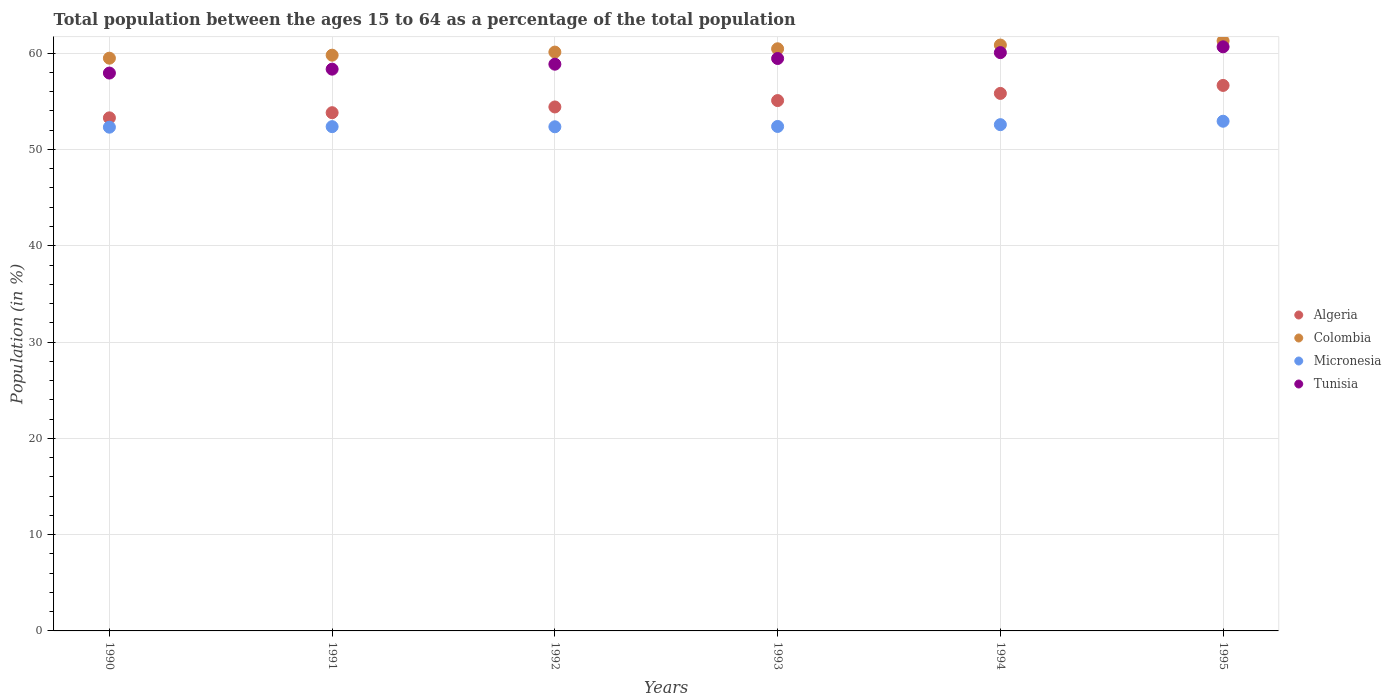How many different coloured dotlines are there?
Your answer should be very brief. 4. Is the number of dotlines equal to the number of legend labels?
Your answer should be compact. Yes. What is the percentage of the population ages 15 to 64 in Colombia in 1991?
Provide a succinct answer. 59.79. Across all years, what is the maximum percentage of the population ages 15 to 64 in Tunisia?
Provide a short and direct response. 60.66. Across all years, what is the minimum percentage of the population ages 15 to 64 in Algeria?
Offer a very short reply. 53.28. In which year was the percentage of the population ages 15 to 64 in Micronesia minimum?
Ensure brevity in your answer.  1990. What is the total percentage of the population ages 15 to 64 in Tunisia in the graph?
Give a very brief answer. 355.3. What is the difference between the percentage of the population ages 15 to 64 in Colombia in 1990 and that in 1992?
Make the answer very short. -0.63. What is the difference between the percentage of the population ages 15 to 64 in Algeria in 1993 and the percentage of the population ages 15 to 64 in Tunisia in 1994?
Offer a terse response. -4.98. What is the average percentage of the population ages 15 to 64 in Tunisia per year?
Offer a very short reply. 59.22. In the year 1992, what is the difference between the percentage of the population ages 15 to 64 in Micronesia and percentage of the population ages 15 to 64 in Tunisia?
Your answer should be compact. -6.5. What is the ratio of the percentage of the population ages 15 to 64 in Algeria in 1991 to that in 1994?
Offer a terse response. 0.96. What is the difference between the highest and the second highest percentage of the population ages 15 to 64 in Colombia?
Offer a very short reply. 0.43. What is the difference between the highest and the lowest percentage of the population ages 15 to 64 in Colombia?
Offer a terse response. 1.8. In how many years, is the percentage of the population ages 15 to 64 in Tunisia greater than the average percentage of the population ages 15 to 64 in Tunisia taken over all years?
Provide a succinct answer. 3. Is it the case that in every year, the sum of the percentage of the population ages 15 to 64 in Algeria and percentage of the population ages 15 to 64 in Tunisia  is greater than the percentage of the population ages 15 to 64 in Colombia?
Give a very brief answer. Yes. Does the percentage of the population ages 15 to 64 in Micronesia monotonically increase over the years?
Give a very brief answer. No. Is the percentage of the population ages 15 to 64 in Micronesia strictly greater than the percentage of the population ages 15 to 64 in Tunisia over the years?
Your answer should be very brief. No. Is the percentage of the population ages 15 to 64 in Colombia strictly less than the percentage of the population ages 15 to 64 in Tunisia over the years?
Your answer should be compact. No. How many years are there in the graph?
Give a very brief answer. 6. What is the difference between two consecutive major ticks on the Y-axis?
Your answer should be very brief. 10. Does the graph contain any zero values?
Offer a very short reply. No. Does the graph contain grids?
Your answer should be very brief. Yes. Where does the legend appear in the graph?
Your answer should be very brief. Center right. What is the title of the graph?
Offer a very short reply. Total population between the ages 15 to 64 as a percentage of the total population. What is the label or title of the X-axis?
Give a very brief answer. Years. What is the label or title of the Y-axis?
Your response must be concise. Population (in %). What is the Population (in %) in Algeria in 1990?
Keep it short and to the point. 53.28. What is the Population (in %) in Colombia in 1990?
Ensure brevity in your answer.  59.48. What is the Population (in %) of Micronesia in 1990?
Ensure brevity in your answer.  52.31. What is the Population (in %) in Tunisia in 1990?
Offer a very short reply. 57.94. What is the Population (in %) of Algeria in 1991?
Give a very brief answer. 53.82. What is the Population (in %) in Colombia in 1991?
Offer a terse response. 59.79. What is the Population (in %) in Micronesia in 1991?
Your answer should be compact. 52.37. What is the Population (in %) in Tunisia in 1991?
Make the answer very short. 58.34. What is the Population (in %) of Algeria in 1992?
Give a very brief answer. 54.42. What is the Population (in %) in Colombia in 1992?
Provide a short and direct response. 60.11. What is the Population (in %) in Micronesia in 1992?
Provide a short and direct response. 52.36. What is the Population (in %) in Tunisia in 1992?
Your answer should be compact. 58.86. What is the Population (in %) in Algeria in 1993?
Give a very brief answer. 55.08. What is the Population (in %) in Colombia in 1993?
Keep it short and to the point. 60.46. What is the Population (in %) in Micronesia in 1993?
Your answer should be very brief. 52.39. What is the Population (in %) in Tunisia in 1993?
Offer a terse response. 59.45. What is the Population (in %) in Algeria in 1994?
Your response must be concise. 55.82. What is the Population (in %) in Colombia in 1994?
Provide a succinct answer. 60.84. What is the Population (in %) in Micronesia in 1994?
Give a very brief answer. 52.58. What is the Population (in %) in Tunisia in 1994?
Give a very brief answer. 60.06. What is the Population (in %) in Algeria in 1995?
Provide a succinct answer. 56.65. What is the Population (in %) of Colombia in 1995?
Make the answer very short. 61.28. What is the Population (in %) of Micronesia in 1995?
Ensure brevity in your answer.  52.93. What is the Population (in %) in Tunisia in 1995?
Keep it short and to the point. 60.66. Across all years, what is the maximum Population (in %) in Algeria?
Offer a very short reply. 56.65. Across all years, what is the maximum Population (in %) in Colombia?
Provide a short and direct response. 61.28. Across all years, what is the maximum Population (in %) in Micronesia?
Your response must be concise. 52.93. Across all years, what is the maximum Population (in %) in Tunisia?
Provide a short and direct response. 60.66. Across all years, what is the minimum Population (in %) of Algeria?
Your answer should be very brief. 53.28. Across all years, what is the minimum Population (in %) of Colombia?
Your answer should be compact. 59.48. Across all years, what is the minimum Population (in %) in Micronesia?
Your answer should be compact. 52.31. Across all years, what is the minimum Population (in %) in Tunisia?
Ensure brevity in your answer.  57.94. What is the total Population (in %) of Algeria in the graph?
Provide a short and direct response. 329.07. What is the total Population (in %) in Colombia in the graph?
Provide a short and direct response. 361.97. What is the total Population (in %) of Micronesia in the graph?
Ensure brevity in your answer.  314.94. What is the total Population (in %) of Tunisia in the graph?
Provide a succinct answer. 355.3. What is the difference between the Population (in %) in Algeria in 1990 and that in 1991?
Offer a very short reply. -0.54. What is the difference between the Population (in %) in Colombia in 1990 and that in 1991?
Provide a succinct answer. -0.31. What is the difference between the Population (in %) in Micronesia in 1990 and that in 1991?
Your answer should be compact. -0.06. What is the difference between the Population (in %) in Tunisia in 1990 and that in 1991?
Ensure brevity in your answer.  -0.41. What is the difference between the Population (in %) in Algeria in 1990 and that in 1992?
Ensure brevity in your answer.  -1.13. What is the difference between the Population (in %) of Colombia in 1990 and that in 1992?
Give a very brief answer. -0.63. What is the difference between the Population (in %) in Micronesia in 1990 and that in 1992?
Provide a succinct answer. -0.04. What is the difference between the Population (in %) in Tunisia in 1990 and that in 1992?
Offer a very short reply. -0.92. What is the difference between the Population (in %) in Algeria in 1990 and that in 1993?
Your response must be concise. -1.8. What is the difference between the Population (in %) in Colombia in 1990 and that in 1993?
Ensure brevity in your answer.  -0.98. What is the difference between the Population (in %) in Micronesia in 1990 and that in 1993?
Give a very brief answer. -0.08. What is the difference between the Population (in %) in Tunisia in 1990 and that in 1993?
Provide a succinct answer. -1.51. What is the difference between the Population (in %) in Algeria in 1990 and that in 1994?
Your answer should be very brief. -2.54. What is the difference between the Population (in %) of Colombia in 1990 and that in 1994?
Keep it short and to the point. -1.36. What is the difference between the Population (in %) of Micronesia in 1990 and that in 1994?
Offer a terse response. -0.26. What is the difference between the Population (in %) in Tunisia in 1990 and that in 1994?
Ensure brevity in your answer.  -2.12. What is the difference between the Population (in %) in Algeria in 1990 and that in 1995?
Offer a very short reply. -3.37. What is the difference between the Population (in %) of Colombia in 1990 and that in 1995?
Your answer should be very brief. -1.8. What is the difference between the Population (in %) in Micronesia in 1990 and that in 1995?
Your answer should be compact. -0.62. What is the difference between the Population (in %) of Tunisia in 1990 and that in 1995?
Your answer should be very brief. -2.73. What is the difference between the Population (in %) in Algeria in 1991 and that in 1992?
Ensure brevity in your answer.  -0.6. What is the difference between the Population (in %) of Colombia in 1991 and that in 1992?
Offer a very short reply. -0.32. What is the difference between the Population (in %) in Micronesia in 1991 and that in 1992?
Offer a terse response. 0.01. What is the difference between the Population (in %) of Tunisia in 1991 and that in 1992?
Your answer should be very brief. -0.52. What is the difference between the Population (in %) of Algeria in 1991 and that in 1993?
Provide a short and direct response. -1.26. What is the difference between the Population (in %) of Colombia in 1991 and that in 1993?
Give a very brief answer. -0.67. What is the difference between the Population (in %) in Micronesia in 1991 and that in 1993?
Give a very brief answer. -0.02. What is the difference between the Population (in %) of Tunisia in 1991 and that in 1993?
Ensure brevity in your answer.  -1.11. What is the difference between the Population (in %) of Algeria in 1991 and that in 1994?
Offer a terse response. -2. What is the difference between the Population (in %) of Colombia in 1991 and that in 1994?
Your answer should be compact. -1.05. What is the difference between the Population (in %) of Micronesia in 1991 and that in 1994?
Keep it short and to the point. -0.21. What is the difference between the Population (in %) of Tunisia in 1991 and that in 1994?
Your response must be concise. -1.72. What is the difference between the Population (in %) in Algeria in 1991 and that in 1995?
Make the answer very short. -2.83. What is the difference between the Population (in %) of Colombia in 1991 and that in 1995?
Offer a very short reply. -1.48. What is the difference between the Population (in %) in Micronesia in 1991 and that in 1995?
Ensure brevity in your answer.  -0.56. What is the difference between the Population (in %) of Tunisia in 1991 and that in 1995?
Provide a succinct answer. -2.32. What is the difference between the Population (in %) of Algeria in 1992 and that in 1993?
Offer a very short reply. -0.66. What is the difference between the Population (in %) of Colombia in 1992 and that in 1993?
Keep it short and to the point. -0.34. What is the difference between the Population (in %) in Micronesia in 1992 and that in 1993?
Your answer should be compact. -0.03. What is the difference between the Population (in %) of Tunisia in 1992 and that in 1993?
Your answer should be very brief. -0.59. What is the difference between the Population (in %) of Algeria in 1992 and that in 1994?
Make the answer very short. -1.41. What is the difference between the Population (in %) of Colombia in 1992 and that in 1994?
Your response must be concise. -0.73. What is the difference between the Population (in %) in Micronesia in 1992 and that in 1994?
Give a very brief answer. -0.22. What is the difference between the Population (in %) in Tunisia in 1992 and that in 1994?
Keep it short and to the point. -1.2. What is the difference between the Population (in %) of Algeria in 1992 and that in 1995?
Give a very brief answer. -2.24. What is the difference between the Population (in %) in Colombia in 1992 and that in 1995?
Make the answer very short. -1.16. What is the difference between the Population (in %) in Micronesia in 1992 and that in 1995?
Your answer should be very brief. -0.58. What is the difference between the Population (in %) of Tunisia in 1992 and that in 1995?
Your answer should be very brief. -1.8. What is the difference between the Population (in %) of Algeria in 1993 and that in 1994?
Offer a very short reply. -0.74. What is the difference between the Population (in %) of Colombia in 1993 and that in 1994?
Your answer should be very brief. -0.39. What is the difference between the Population (in %) in Micronesia in 1993 and that in 1994?
Make the answer very short. -0.19. What is the difference between the Population (in %) of Tunisia in 1993 and that in 1994?
Give a very brief answer. -0.61. What is the difference between the Population (in %) in Algeria in 1993 and that in 1995?
Keep it short and to the point. -1.57. What is the difference between the Population (in %) of Colombia in 1993 and that in 1995?
Offer a terse response. -0.82. What is the difference between the Population (in %) of Micronesia in 1993 and that in 1995?
Your response must be concise. -0.54. What is the difference between the Population (in %) of Tunisia in 1993 and that in 1995?
Give a very brief answer. -1.21. What is the difference between the Population (in %) of Algeria in 1994 and that in 1995?
Provide a succinct answer. -0.83. What is the difference between the Population (in %) of Colombia in 1994 and that in 1995?
Make the answer very short. -0.43. What is the difference between the Population (in %) of Micronesia in 1994 and that in 1995?
Make the answer very short. -0.36. What is the difference between the Population (in %) of Tunisia in 1994 and that in 1995?
Provide a short and direct response. -0.6. What is the difference between the Population (in %) of Algeria in 1990 and the Population (in %) of Colombia in 1991?
Offer a terse response. -6.51. What is the difference between the Population (in %) in Algeria in 1990 and the Population (in %) in Tunisia in 1991?
Your answer should be very brief. -5.06. What is the difference between the Population (in %) in Colombia in 1990 and the Population (in %) in Micronesia in 1991?
Provide a short and direct response. 7.11. What is the difference between the Population (in %) in Colombia in 1990 and the Population (in %) in Tunisia in 1991?
Your answer should be very brief. 1.14. What is the difference between the Population (in %) in Micronesia in 1990 and the Population (in %) in Tunisia in 1991?
Ensure brevity in your answer.  -6.03. What is the difference between the Population (in %) in Algeria in 1990 and the Population (in %) in Colombia in 1992?
Ensure brevity in your answer.  -6.83. What is the difference between the Population (in %) in Algeria in 1990 and the Population (in %) in Micronesia in 1992?
Provide a succinct answer. 0.93. What is the difference between the Population (in %) in Algeria in 1990 and the Population (in %) in Tunisia in 1992?
Make the answer very short. -5.57. What is the difference between the Population (in %) of Colombia in 1990 and the Population (in %) of Micronesia in 1992?
Provide a short and direct response. 7.12. What is the difference between the Population (in %) in Colombia in 1990 and the Population (in %) in Tunisia in 1992?
Your answer should be compact. 0.62. What is the difference between the Population (in %) in Micronesia in 1990 and the Population (in %) in Tunisia in 1992?
Your answer should be very brief. -6.54. What is the difference between the Population (in %) of Algeria in 1990 and the Population (in %) of Colombia in 1993?
Provide a succinct answer. -7.17. What is the difference between the Population (in %) in Algeria in 1990 and the Population (in %) in Micronesia in 1993?
Your answer should be compact. 0.89. What is the difference between the Population (in %) of Algeria in 1990 and the Population (in %) of Tunisia in 1993?
Ensure brevity in your answer.  -6.16. What is the difference between the Population (in %) in Colombia in 1990 and the Population (in %) in Micronesia in 1993?
Your answer should be very brief. 7.09. What is the difference between the Population (in %) of Colombia in 1990 and the Population (in %) of Tunisia in 1993?
Your answer should be compact. 0.03. What is the difference between the Population (in %) of Micronesia in 1990 and the Population (in %) of Tunisia in 1993?
Offer a terse response. -7.13. What is the difference between the Population (in %) of Algeria in 1990 and the Population (in %) of Colombia in 1994?
Offer a very short reply. -7.56. What is the difference between the Population (in %) of Algeria in 1990 and the Population (in %) of Micronesia in 1994?
Keep it short and to the point. 0.71. What is the difference between the Population (in %) in Algeria in 1990 and the Population (in %) in Tunisia in 1994?
Provide a short and direct response. -6.77. What is the difference between the Population (in %) of Colombia in 1990 and the Population (in %) of Micronesia in 1994?
Provide a succinct answer. 6.9. What is the difference between the Population (in %) in Colombia in 1990 and the Population (in %) in Tunisia in 1994?
Keep it short and to the point. -0.58. What is the difference between the Population (in %) of Micronesia in 1990 and the Population (in %) of Tunisia in 1994?
Keep it short and to the point. -7.74. What is the difference between the Population (in %) in Algeria in 1990 and the Population (in %) in Colombia in 1995?
Offer a terse response. -7.99. What is the difference between the Population (in %) of Algeria in 1990 and the Population (in %) of Micronesia in 1995?
Your answer should be very brief. 0.35. What is the difference between the Population (in %) in Algeria in 1990 and the Population (in %) in Tunisia in 1995?
Make the answer very short. -7.38. What is the difference between the Population (in %) of Colombia in 1990 and the Population (in %) of Micronesia in 1995?
Make the answer very short. 6.55. What is the difference between the Population (in %) of Colombia in 1990 and the Population (in %) of Tunisia in 1995?
Provide a succinct answer. -1.18. What is the difference between the Population (in %) in Micronesia in 1990 and the Population (in %) in Tunisia in 1995?
Keep it short and to the point. -8.35. What is the difference between the Population (in %) in Algeria in 1991 and the Population (in %) in Colombia in 1992?
Offer a very short reply. -6.29. What is the difference between the Population (in %) of Algeria in 1991 and the Population (in %) of Micronesia in 1992?
Ensure brevity in your answer.  1.46. What is the difference between the Population (in %) in Algeria in 1991 and the Population (in %) in Tunisia in 1992?
Keep it short and to the point. -5.04. What is the difference between the Population (in %) in Colombia in 1991 and the Population (in %) in Micronesia in 1992?
Keep it short and to the point. 7.44. What is the difference between the Population (in %) of Colombia in 1991 and the Population (in %) of Tunisia in 1992?
Offer a terse response. 0.94. What is the difference between the Population (in %) of Micronesia in 1991 and the Population (in %) of Tunisia in 1992?
Make the answer very short. -6.49. What is the difference between the Population (in %) of Algeria in 1991 and the Population (in %) of Colombia in 1993?
Provide a short and direct response. -6.64. What is the difference between the Population (in %) in Algeria in 1991 and the Population (in %) in Micronesia in 1993?
Offer a terse response. 1.43. What is the difference between the Population (in %) of Algeria in 1991 and the Population (in %) of Tunisia in 1993?
Offer a very short reply. -5.63. What is the difference between the Population (in %) in Colombia in 1991 and the Population (in %) in Micronesia in 1993?
Offer a terse response. 7.4. What is the difference between the Population (in %) of Colombia in 1991 and the Population (in %) of Tunisia in 1993?
Make the answer very short. 0.35. What is the difference between the Population (in %) of Micronesia in 1991 and the Population (in %) of Tunisia in 1993?
Your answer should be compact. -7.08. What is the difference between the Population (in %) in Algeria in 1991 and the Population (in %) in Colombia in 1994?
Provide a succinct answer. -7.03. What is the difference between the Population (in %) in Algeria in 1991 and the Population (in %) in Micronesia in 1994?
Offer a terse response. 1.24. What is the difference between the Population (in %) of Algeria in 1991 and the Population (in %) of Tunisia in 1994?
Your answer should be compact. -6.24. What is the difference between the Population (in %) of Colombia in 1991 and the Population (in %) of Micronesia in 1994?
Ensure brevity in your answer.  7.22. What is the difference between the Population (in %) in Colombia in 1991 and the Population (in %) in Tunisia in 1994?
Make the answer very short. -0.27. What is the difference between the Population (in %) in Micronesia in 1991 and the Population (in %) in Tunisia in 1994?
Your response must be concise. -7.69. What is the difference between the Population (in %) of Algeria in 1991 and the Population (in %) of Colombia in 1995?
Offer a terse response. -7.46. What is the difference between the Population (in %) of Algeria in 1991 and the Population (in %) of Micronesia in 1995?
Your answer should be very brief. 0.89. What is the difference between the Population (in %) of Algeria in 1991 and the Population (in %) of Tunisia in 1995?
Your answer should be compact. -6.84. What is the difference between the Population (in %) in Colombia in 1991 and the Population (in %) in Micronesia in 1995?
Make the answer very short. 6.86. What is the difference between the Population (in %) in Colombia in 1991 and the Population (in %) in Tunisia in 1995?
Your response must be concise. -0.87. What is the difference between the Population (in %) in Micronesia in 1991 and the Population (in %) in Tunisia in 1995?
Give a very brief answer. -8.29. What is the difference between the Population (in %) in Algeria in 1992 and the Population (in %) in Colombia in 1993?
Your response must be concise. -6.04. What is the difference between the Population (in %) in Algeria in 1992 and the Population (in %) in Micronesia in 1993?
Provide a succinct answer. 2.03. What is the difference between the Population (in %) in Algeria in 1992 and the Population (in %) in Tunisia in 1993?
Offer a terse response. -5.03. What is the difference between the Population (in %) in Colombia in 1992 and the Population (in %) in Micronesia in 1993?
Provide a short and direct response. 7.72. What is the difference between the Population (in %) of Colombia in 1992 and the Population (in %) of Tunisia in 1993?
Provide a short and direct response. 0.67. What is the difference between the Population (in %) in Micronesia in 1992 and the Population (in %) in Tunisia in 1993?
Give a very brief answer. -7.09. What is the difference between the Population (in %) in Algeria in 1992 and the Population (in %) in Colombia in 1994?
Keep it short and to the point. -6.43. What is the difference between the Population (in %) in Algeria in 1992 and the Population (in %) in Micronesia in 1994?
Your response must be concise. 1.84. What is the difference between the Population (in %) in Algeria in 1992 and the Population (in %) in Tunisia in 1994?
Your answer should be compact. -5.64. What is the difference between the Population (in %) of Colombia in 1992 and the Population (in %) of Micronesia in 1994?
Your answer should be compact. 7.54. What is the difference between the Population (in %) in Colombia in 1992 and the Population (in %) in Tunisia in 1994?
Give a very brief answer. 0.05. What is the difference between the Population (in %) of Micronesia in 1992 and the Population (in %) of Tunisia in 1994?
Provide a short and direct response. -7.7. What is the difference between the Population (in %) of Algeria in 1992 and the Population (in %) of Colombia in 1995?
Provide a succinct answer. -6.86. What is the difference between the Population (in %) in Algeria in 1992 and the Population (in %) in Micronesia in 1995?
Give a very brief answer. 1.48. What is the difference between the Population (in %) in Algeria in 1992 and the Population (in %) in Tunisia in 1995?
Keep it short and to the point. -6.24. What is the difference between the Population (in %) of Colombia in 1992 and the Population (in %) of Micronesia in 1995?
Ensure brevity in your answer.  7.18. What is the difference between the Population (in %) of Colombia in 1992 and the Population (in %) of Tunisia in 1995?
Make the answer very short. -0.55. What is the difference between the Population (in %) in Micronesia in 1992 and the Population (in %) in Tunisia in 1995?
Your response must be concise. -8.3. What is the difference between the Population (in %) in Algeria in 1993 and the Population (in %) in Colombia in 1994?
Your answer should be compact. -5.77. What is the difference between the Population (in %) of Algeria in 1993 and the Population (in %) of Micronesia in 1994?
Offer a very short reply. 2.5. What is the difference between the Population (in %) of Algeria in 1993 and the Population (in %) of Tunisia in 1994?
Keep it short and to the point. -4.98. What is the difference between the Population (in %) in Colombia in 1993 and the Population (in %) in Micronesia in 1994?
Your response must be concise. 7.88. What is the difference between the Population (in %) in Colombia in 1993 and the Population (in %) in Tunisia in 1994?
Make the answer very short. 0.4. What is the difference between the Population (in %) of Micronesia in 1993 and the Population (in %) of Tunisia in 1994?
Offer a very short reply. -7.67. What is the difference between the Population (in %) of Algeria in 1993 and the Population (in %) of Colombia in 1995?
Your answer should be compact. -6.2. What is the difference between the Population (in %) of Algeria in 1993 and the Population (in %) of Micronesia in 1995?
Offer a very short reply. 2.15. What is the difference between the Population (in %) of Algeria in 1993 and the Population (in %) of Tunisia in 1995?
Give a very brief answer. -5.58. What is the difference between the Population (in %) of Colombia in 1993 and the Population (in %) of Micronesia in 1995?
Offer a very short reply. 7.53. What is the difference between the Population (in %) in Colombia in 1993 and the Population (in %) in Tunisia in 1995?
Offer a terse response. -0.2. What is the difference between the Population (in %) in Micronesia in 1993 and the Population (in %) in Tunisia in 1995?
Your answer should be very brief. -8.27. What is the difference between the Population (in %) of Algeria in 1994 and the Population (in %) of Colombia in 1995?
Your answer should be compact. -5.45. What is the difference between the Population (in %) of Algeria in 1994 and the Population (in %) of Micronesia in 1995?
Your answer should be compact. 2.89. What is the difference between the Population (in %) of Algeria in 1994 and the Population (in %) of Tunisia in 1995?
Give a very brief answer. -4.84. What is the difference between the Population (in %) of Colombia in 1994 and the Population (in %) of Micronesia in 1995?
Keep it short and to the point. 7.91. What is the difference between the Population (in %) of Colombia in 1994 and the Population (in %) of Tunisia in 1995?
Ensure brevity in your answer.  0.18. What is the difference between the Population (in %) in Micronesia in 1994 and the Population (in %) in Tunisia in 1995?
Make the answer very short. -8.08. What is the average Population (in %) in Algeria per year?
Keep it short and to the point. 54.84. What is the average Population (in %) of Colombia per year?
Give a very brief answer. 60.33. What is the average Population (in %) in Micronesia per year?
Your response must be concise. 52.49. What is the average Population (in %) of Tunisia per year?
Your answer should be compact. 59.22. In the year 1990, what is the difference between the Population (in %) of Algeria and Population (in %) of Colombia?
Make the answer very short. -6.2. In the year 1990, what is the difference between the Population (in %) in Algeria and Population (in %) in Micronesia?
Keep it short and to the point. 0.97. In the year 1990, what is the difference between the Population (in %) of Algeria and Population (in %) of Tunisia?
Your answer should be very brief. -4.65. In the year 1990, what is the difference between the Population (in %) in Colombia and Population (in %) in Micronesia?
Provide a succinct answer. 7.17. In the year 1990, what is the difference between the Population (in %) of Colombia and Population (in %) of Tunisia?
Make the answer very short. 1.55. In the year 1990, what is the difference between the Population (in %) in Micronesia and Population (in %) in Tunisia?
Offer a terse response. -5.62. In the year 1991, what is the difference between the Population (in %) of Algeria and Population (in %) of Colombia?
Your response must be concise. -5.97. In the year 1991, what is the difference between the Population (in %) in Algeria and Population (in %) in Micronesia?
Your answer should be very brief. 1.45. In the year 1991, what is the difference between the Population (in %) of Algeria and Population (in %) of Tunisia?
Give a very brief answer. -4.52. In the year 1991, what is the difference between the Population (in %) in Colombia and Population (in %) in Micronesia?
Offer a terse response. 7.42. In the year 1991, what is the difference between the Population (in %) in Colombia and Population (in %) in Tunisia?
Offer a terse response. 1.45. In the year 1991, what is the difference between the Population (in %) in Micronesia and Population (in %) in Tunisia?
Offer a very short reply. -5.97. In the year 1992, what is the difference between the Population (in %) in Algeria and Population (in %) in Colombia?
Keep it short and to the point. -5.7. In the year 1992, what is the difference between the Population (in %) of Algeria and Population (in %) of Micronesia?
Provide a short and direct response. 2.06. In the year 1992, what is the difference between the Population (in %) in Algeria and Population (in %) in Tunisia?
Give a very brief answer. -4.44. In the year 1992, what is the difference between the Population (in %) in Colombia and Population (in %) in Micronesia?
Ensure brevity in your answer.  7.76. In the year 1992, what is the difference between the Population (in %) in Colombia and Population (in %) in Tunisia?
Give a very brief answer. 1.26. In the year 1992, what is the difference between the Population (in %) in Micronesia and Population (in %) in Tunisia?
Offer a terse response. -6.5. In the year 1993, what is the difference between the Population (in %) in Algeria and Population (in %) in Colombia?
Offer a terse response. -5.38. In the year 1993, what is the difference between the Population (in %) of Algeria and Population (in %) of Micronesia?
Provide a succinct answer. 2.69. In the year 1993, what is the difference between the Population (in %) of Algeria and Population (in %) of Tunisia?
Give a very brief answer. -4.37. In the year 1993, what is the difference between the Population (in %) in Colombia and Population (in %) in Micronesia?
Offer a very short reply. 8.07. In the year 1993, what is the difference between the Population (in %) in Colombia and Population (in %) in Tunisia?
Your response must be concise. 1.01. In the year 1993, what is the difference between the Population (in %) in Micronesia and Population (in %) in Tunisia?
Give a very brief answer. -7.06. In the year 1994, what is the difference between the Population (in %) in Algeria and Population (in %) in Colombia?
Offer a very short reply. -5.02. In the year 1994, what is the difference between the Population (in %) of Algeria and Population (in %) of Micronesia?
Give a very brief answer. 3.25. In the year 1994, what is the difference between the Population (in %) in Algeria and Population (in %) in Tunisia?
Ensure brevity in your answer.  -4.24. In the year 1994, what is the difference between the Population (in %) in Colombia and Population (in %) in Micronesia?
Offer a terse response. 8.27. In the year 1994, what is the difference between the Population (in %) of Colombia and Population (in %) of Tunisia?
Provide a succinct answer. 0.79. In the year 1994, what is the difference between the Population (in %) in Micronesia and Population (in %) in Tunisia?
Your answer should be compact. -7.48. In the year 1995, what is the difference between the Population (in %) of Algeria and Population (in %) of Colombia?
Your answer should be very brief. -4.62. In the year 1995, what is the difference between the Population (in %) in Algeria and Population (in %) in Micronesia?
Your answer should be compact. 3.72. In the year 1995, what is the difference between the Population (in %) of Algeria and Population (in %) of Tunisia?
Provide a succinct answer. -4.01. In the year 1995, what is the difference between the Population (in %) in Colombia and Population (in %) in Micronesia?
Your answer should be compact. 8.34. In the year 1995, what is the difference between the Population (in %) of Colombia and Population (in %) of Tunisia?
Offer a very short reply. 0.62. In the year 1995, what is the difference between the Population (in %) in Micronesia and Population (in %) in Tunisia?
Make the answer very short. -7.73. What is the ratio of the Population (in %) of Algeria in 1990 to that in 1991?
Offer a terse response. 0.99. What is the ratio of the Population (in %) in Colombia in 1990 to that in 1991?
Provide a short and direct response. 0.99. What is the ratio of the Population (in %) of Micronesia in 1990 to that in 1991?
Your answer should be compact. 1. What is the ratio of the Population (in %) of Algeria in 1990 to that in 1992?
Provide a short and direct response. 0.98. What is the ratio of the Population (in %) in Tunisia in 1990 to that in 1992?
Make the answer very short. 0.98. What is the ratio of the Population (in %) of Algeria in 1990 to that in 1993?
Your response must be concise. 0.97. What is the ratio of the Population (in %) in Colombia in 1990 to that in 1993?
Keep it short and to the point. 0.98. What is the ratio of the Population (in %) of Tunisia in 1990 to that in 1993?
Ensure brevity in your answer.  0.97. What is the ratio of the Population (in %) of Algeria in 1990 to that in 1994?
Your response must be concise. 0.95. What is the ratio of the Population (in %) of Colombia in 1990 to that in 1994?
Make the answer very short. 0.98. What is the ratio of the Population (in %) of Micronesia in 1990 to that in 1994?
Provide a succinct answer. 0.99. What is the ratio of the Population (in %) in Tunisia in 1990 to that in 1994?
Ensure brevity in your answer.  0.96. What is the ratio of the Population (in %) in Algeria in 1990 to that in 1995?
Provide a succinct answer. 0.94. What is the ratio of the Population (in %) of Colombia in 1990 to that in 1995?
Give a very brief answer. 0.97. What is the ratio of the Population (in %) of Micronesia in 1990 to that in 1995?
Provide a succinct answer. 0.99. What is the ratio of the Population (in %) of Tunisia in 1990 to that in 1995?
Your answer should be compact. 0.96. What is the ratio of the Population (in %) of Colombia in 1991 to that in 1992?
Your answer should be compact. 0.99. What is the ratio of the Population (in %) of Algeria in 1991 to that in 1993?
Offer a terse response. 0.98. What is the ratio of the Population (in %) of Tunisia in 1991 to that in 1993?
Make the answer very short. 0.98. What is the ratio of the Population (in %) in Algeria in 1991 to that in 1994?
Your response must be concise. 0.96. What is the ratio of the Population (in %) in Colombia in 1991 to that in 1994?
Provide a succinct answer. 0.98. What is the ratio of the Population (in %) of Micronesia in 1991 to that in 1994?
Your answer should be very brief. 1. What is the ratio of the Population (in %) in Tunisia in 1991 to that in 1994?
Keep it short and to the point. 0.97. What is the ratio of the Population (in %) of Algeria in 1991 to that in 1995?
Ensure brevity in your answer.  0.95. What is the ratio of the Population (in %) of Colombia in 1991 to that in 1995?
Offer a very short reply. 0.98. What is the ratio of the Population (in %) of Micronesia in 1991 to that in 1995?
Ensure brevity in your answer.  0.99. What is the ratio of the Population (in %) of Tunisia in 1991 to that in 1995?
Offer a terse response. 0.96. What is the ratio of the Population (in %) in Algeria in 1992 to that in 1993?
Make the answer very short. 0.99. What is the ratio of the Population (in %) in Micronesia in 1992 to that in 1993?
Offer a very short reply. 1. What is the ratio of the Population (in %) of Algeria in 1992 to that in 1994?
Ensure brevity in your answer.  0.97. What is the ratio of the Population (in %) in Colombia in 1992 to that in 1994?
Make the answer very short. 0.99. What is the ratio of the Population (in %) in Micronesia in 1992 to that in 1994?
Provide a succinct answer. 1. What is the ratio of the Population (in %) of Tunisia in 1992 to that in 1994?
Your answer should be very brief. 0.98. What is the ratio of the Population (in %) of Algeria in 1992 to that in 1995?
Keep it short and to the point. 0.96. What is the ratio of the Population (in %) of Tunisia in 1992 to that in 1995?
Keep it short and to the point. 0.97. What is the ratio of the Population (in %) in Algeria in 1993 to that in 1994?
Provide a succinct answer. 0.99. What is the ratio of the Population (in %) in Algeria in 1993 to that in 1995?
Offer a terse response. 0.97. What is the ratio of the Population (in %) in Colombia in 1993 to that in 1995?
Offer a terse response. 0.99. What is the ratio of the Population (in %) in Micronesia in 1993 to that in 1995?
Provide a succinct answer. 0.99. What is the ratio of the Population (in %) of Algeria in 1994 to that in 1995?
Offer a terse response. 0.99. What is the ratio of the Population (in %) in Colombia in 1994 to that in 1995?
Your answer should be very brief. 0.99. What is the difference between the highest and the second highest Population (in %) of Algeria?
Provide a short and direct response. 0.83. What is the difference between the highest and the second highest Population (in %) in Colombia?
Your answer should be very brief. 0.43. What is the difference between the highest and the second highest Population (in %) in Micronesia?
Your response must be concise. 0.36. What is the difference between the highest and the second highest Population (in %) in Tunisia?
Provide a short and direct response. 0.6. What is the difference between the highest and the lowest Population (in %) of Algeria?
Offer a very short reply. 3.37. What is the difference between the highest and the lowest Population (in %) in Colombia?
Your answer should be compact. 1.8. What is the difference between the highest and the lowest Population (in %) of Micronesia?
Your response must be concise. 0.62. What is the difference between the highest and the lowest Population (in %) of Tunisia?
Ensure brevity in your answer.  2.73. 